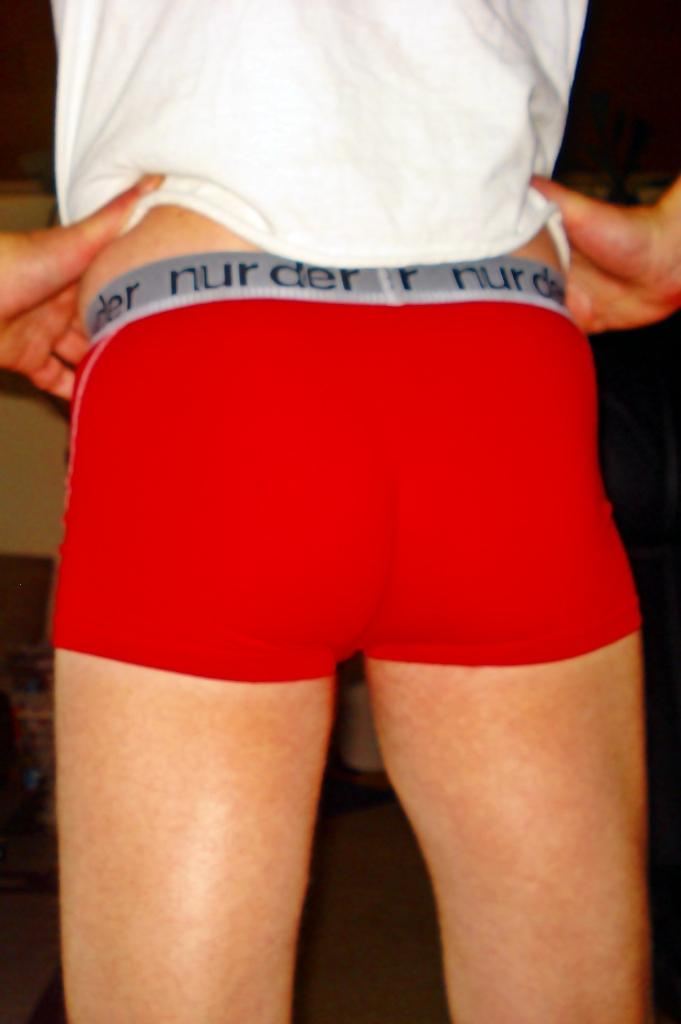<image>
Share a concise interpretation of the image provided. Man wearing underwear that says "nurder" on the strap. 